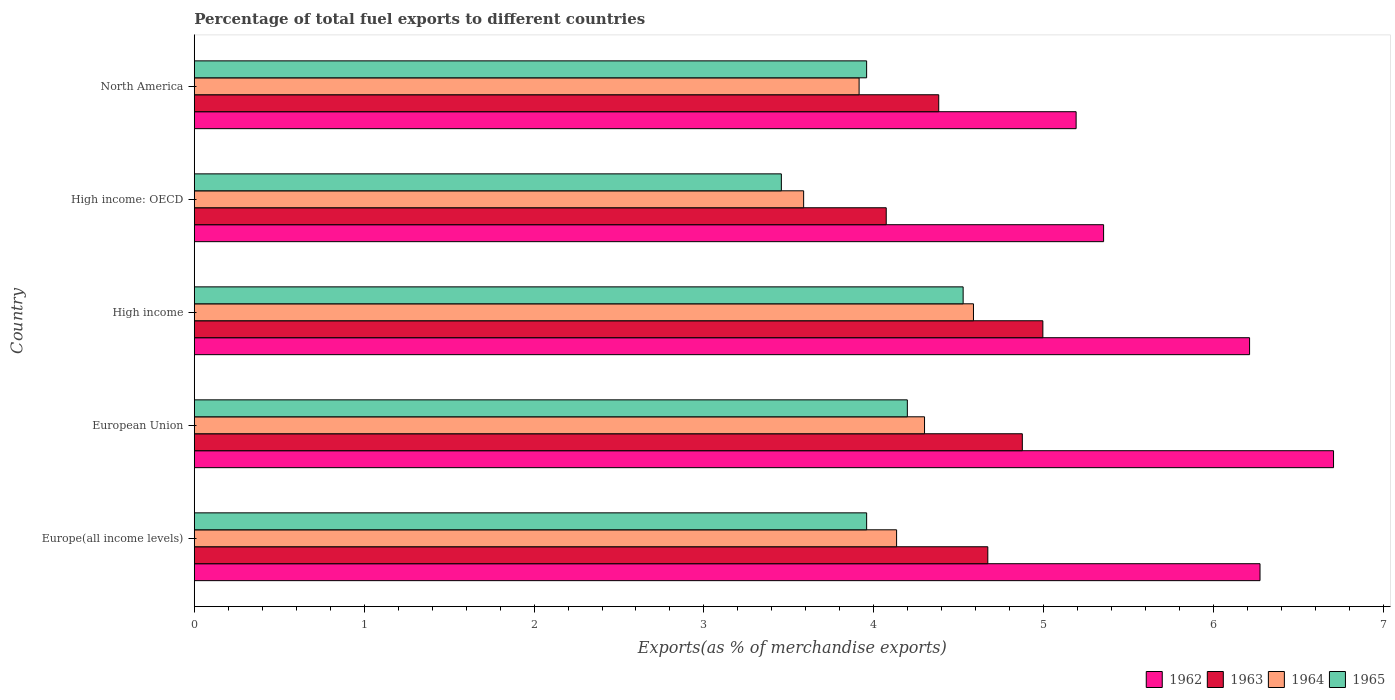How many groups of bars are there?
Make the answer very short. 5. Are the number of bars per tick equal to the number of legend labels?
Make the answer very short. Yes. What is the percentage of exports to different countries in 1963 in High income: OECD?
Give a very brief answer. 4.07. Across all countries, what is the maximum percentage of exports to different countries in 1965?
Provide a short and direct response. 4.53. Across all countries, what is the minimum percentage of exports to different countries in 1964?
Offer a terse response. 3.59. In which country was the percentage of exports to different countries in 1965 maximum?
Make the answer very short. High income. In which country was the percentage of exports to different countries in 1963 minimum?
Your answer should be compact. High income: OECD. What is the total percentage of exports to different countries in 1964 in the graph?
Provide a short and direct response. 20.52. What is the difference between the percentage of exports to different countries in 1962 in Europe(all income levels) and that in High income?
Your answer should be compact. 0.06. What is the difference between the percentage of exports to different countries in 1965 in North America and the percentage of exports to different countries in 1963 in Europe(all income levels)?
Offer a very short reply. -0.71. What is the average percentage of exports to different countries in 1962 per country?
Your response must be concise. 5.95. What is the difference between the percentage of exports to different countries in 1965 and percentage of exports to different countries in 1963 in Europe(all income levels)?
Offer a very short reply. -0.71. In how many countries, is the percentage of exports to different countries in 1964 greater than 5 %?
Provide a succinct answer. 0. What is the ratio of the percentage of exports to different countries in 1964 in European Union to that in High income: OECD?
Keep it short and to the point. 1.2. What is the difference between the highest and the second highest percentage of exports to different countries in 1964?
Offer a very short reply. 0.29. What is the difference between the highest and the lowest percentage of exports to different countries in 1962?
Your answer should be compact. 1.52. Is it the case that in every country, the sum of the percentage of exports to different countries in 1965 and percentage of exports to different countries in 1964 is greater than the sum of percentage of exports to different countries in 1962 and percentage of exports to different countries in 1963?
Give a very brief answer. No. What does the 4th bar from the top in Europe(all income levels) represents?
Keep it short and to the point. 1962. What does the 4th bar from the bottom in European Union represents?
Ensure brevity in your answer.  1965. How many bars are there?
Ensure brevity in your answer.  20. Are all the bars in the graph horizontal?
Your answer should be very brief. Yes. How many countries are there in the graph?
Provide a succinct answer. 5. What is the difference between two consecutive major ticks on the X-axis?
Your answer should be very brief. 1. Does the graph contain any zero values?
Ensure brevity in your answer.  No. Where does the legend appear in the graph?
Give a very brief answer. Bottom right. How many legend labels are there?
Make the answer very short. 4. How are the legend labels stacked?
Make the answer very short. Horizontal. What is the title of the graph?
Offer a very short reply. Percentage of total fuel exports to different countries. What is the label or title of the X-axis?
Provide a succinct answer. Exports(as % of merchandise exports). What is the Exports(as % of merchandise exports) in 1962 in Europe(all income levels)?
Make the answer very short. 6.27. What is the Exports(as % of merchandise exports) of 1963 in Europe(all income levels)?
Provide a succinct answer. 4.67. What is the Exports(as % of merchandise exports) of 1964 in Europe(all income levels)?
Your answer should be very brief. 4.13. What is the Exports(as % of merchandise exports) of 1965 in Europe(all income levels)?
Make the answer very short. 3.96. What is the Exports(as % of merchandise exports) of 1962 in European Union?
Offer a very short reply. 6.71. What is the Exports(as % of merchandise exports) in 1963 in European Union?
Provide a succinct answer. 4.87. What is the Exports(as % of merchandise exports) in 1964 in European Union?
Offer a very short reply. 4.3. What is the Exports(as % of merchandise exports) of 1965 in European Union?
Offer a terse response. 4.2. What is the Exports(as % of merchandise exports) of 1962 in High income?
Make the answer very short. 6.21. What is the Exports(as % of merchandise exports) of 1963 in High income?
Provide a short and direct response. 5. What is the Exports(as % of merchandise exports) of 1964 in High income?
Make the answer very short. 4.59. What is the Exports(as % of merchandise exports) in 1965 in High income?
Your answer should be very brief. 4.53. What is the Exports(as % of merchandise exports) in 1962 in High income: OECD?
Offer a terse response. 5.35. What is the Exports(as % of merchandise exports) in 1963 in High income: OECD?
Keep it short and to the point. 4.07. What is the Exports(as % of merchandise exports) of 1964 in High income: OECD?
Keep it short and to the point. 3.59. What is the Exports(as % of merchandise exports) of 1965 in High income: OECD?
Keep it short and to the point. 3.46. What is the Exports(as % of merchandise exports) of 1962 in North America?
Offer a terse response. 5.19. What is the Exports(as % of merchandise exports) of 1963 in North America?
Make the answer very short. 4.38. What is the Exports(as % of merchandise exports) of 1964 in North America?
Make the answer very short. 3.91. What is the Exports(as % of merchandise exports) in 1965 in North America?
Your response must be concise. 3.96. Across all countries, what is the maximum Exports(as % of merchandise exports) of 1962?
Offer a very short reply. 6.71. Across all countries, what is the maximum Exports(as % of merchandise exports) of 1963?
Provide a short and direct response. 5. Across all countries, what is the maximum Exports(as % of merchandise exports) in 1964?
Your answer should be compact. 4.59. Across all countries, what is the maximum Exports(as % of merchandise exports) in 1965?
Keep it short and to the point. 4.53. Across all countries, what is the minimum Exports(as % of merchandise exports) of 1962?
Offer a very short reply. 5.19. Across all countries, what is the minimum Exports(as % of merchandise exports) of 1963?
Offer a terse response. 4.07. Across all countries, what is the minimum Exports(as % of merchandise exports) in 1964?
Offer a very short reply. 3.59. Across all countries, what is the minimum Exports(as % of merchandise exports) in 1965?
Give a very brief answer. 3.46. What is the total Exports(as % of merchandise exports) in 1962 in the graph?
Your response must be concise. 29.73. What is the total Exports(as % of merchandise exports) of 1963 in the graph?
Your answer should be compact. 23. What is the total Exports(as % of merchandise exports) of 1964 in the graph?
Offer a very short reply. 20.52. What is the total Exports(as % of merchandise exports) of 1965 in the graph?
Ensure brevity in your answer.  20.09. What is the difference between the Exports(as % of merchandise exports) of 1962 in Europe(all income levels) and that in European Union?
Offer a terse response. -0.43. What is the difference between the Exports(as % of merchandise exports) of 1963 in Europe(all income levels) and that in European Union?
Your response must be concise. -0.2. What is the difference between the Exports(as % of merchandise exports) of 1964 in Europe(all income levels) and that in European Union?
Provide a succinct answer. -0.16. What is the difference between the Exports(as % of merchandise exports) of 1965 in Europe(all income levels) and that in European Union?
Keep it short and to the point. -0.24. What is the difference between the Exports(as % of merchandise exports) in 1962 in Europe(all income levels) and that in High income?
Make the answer very short. 0.06. What is the difference between the Exports(as % of merchandise exports) of 1963 in Europe(all income levels) and that in High income?
Your response must be concise. -0.32. What is the difference between the Exports(as % of merchandise exports) in 1964 in Europe(all income levels) and that in High income?
Offer a very short reply. -0.45. What is the difference between the Exports(as % of merchandise exports) of 1965 in Europe(all income levels) and that in High income?
Provide a short and direct response. -0.57. What is the difference between the Exports(as % of merchandise exports) of 1962 in Europe(all income levels) and that in High income: OECD?
Your response must be concise. 0.92. What is the difference between the Exports(as % of merchandise exports) of 1963 in Europe(all income levels) and that in High income: OECD?
Ensure brevity in your answer.  0.6. What is the difference between the Exports(as % of merchandise exports) in 1964 in Europe(all income levels) and that in High income: OECD?
Your response must be concise. 0.55. What is the difference between the Exports(as % of merchandise exports) in 1965 in Europe(all income levels) and that in High income: OECD?
Your answer should be very brief. 0.5. What is the difference between the Exports(as % of merchandise exports) in 1962 in Europe(all income levels) and that in North America?
Your answer should be very brief. 1.08. What is the difference between the Exports(as % of merchandise exports) of 1963 in Europe(all income levels) and that in North America?
Ensure brevity in your answer.  0.29. What is the difference between the Exports(as % of merchandise exports) in 1964 in Europe(all income levels) and that in North America?
Give a very brief answer. 0.22. What is the difference between the Exports(as % of merchandise exports) in 1962 in European Union and that in High income?
Offer a very short reply. 0.49. What is the difference between the Exports(as % of merchandise exports) of 1963 in European Union and that in High income?
Your response must be concise. -0.12. What is the difference between the Exports(as % of merchandise exports) of 1964 in European Union and that in High income?
Ensure brevity in your answer.  -0.29. What is the difference between the Exports(as % of merchandise exports) of 1965 in European Union and that in High income?
Provide a succinct answer. -0.33. What is the difference between the Exports(as % of merchandise exports) of 1962 in European Union and that in High income: OECD?
Make the answer very short. 1.35. What is the difference between the Exports(as % of merchandise exports) of 1963 in European Union and that in High income: OECD?
Provide a short and direct response. 0.8. What is the difference between the Exports(as % of merchandise exports) of 1964 in European Union and that in High income: OECD?
Keep it short and to the point. 0.71. What is the difference between the Exports(as % of merchandise exports) of 1965 in European Union and that in High income: OECD?
Give a very brief answer. 0.74. What is the difference between the Exports(as % of merchandise exports) of 1962 in European Union and that in North America?
Give a very brief answer. 1.52. What is the difference between the Exports(as % of merchandise exports) in 1963 in European Union and that in North America?
Your answer should be compact. 0.49. What is the difference between the Exports(as % of merchandise exports) of 1964 in European Union and that in North America?
Ensure brevity in your answer.  0.39. What is the difference between the Exports(as % of merchandise exports) of 1965 in European Union and that in North America?
Provide a succinct answer. 0.24. What is the difference between the Exports(as % of merchandise exports) of 1962 in High income and that in High income: OECD?
Provide a succinct answer. 0.86. What is the difference between the Exports(as % of merchandise exports) of 1963 in High income and that in High income: OECD?
Give a very brief answer. 0.92. What is the difference between the Exports(as % of merchandise exports) in 1965 in High income and that in High income: OECD?
Offer a very short reply. 1.07. What is the difference between the Exports(as % of merchandise exports) of 1962 in High income and that in North America?
Keep it short and to the point. 1.02. What is the difference between the Exports(as % of merchandise exports) of 1963 in High income and that in North America?
Offer a very short reply. 0.61. What is the difference between the Exports(as % of merchandise exports) of 1964 in High income and that in North America?
Ensure brevity in your answer.  0.67. What is the difference between the Exports(as % of merchandise exports) in 1965 in High income and that in North America?
Give a very brief answer. 0.57. What is the difference between the Exports(as % of merchandise exports) in 1962 in High income: OECD and that in North America?
Offer a very short reply. 0.16. What is the difference between the Exports(as % of merchandise exports) of 1963 in High income: OECD and that in North America?
Offer a terse response. -0.31. What is the difference between the Exports(as % of merchandise exports) of 1964 in High income: OECD and that in North America?
Keep it short and to the point. -0.33. What is the difference between the Exports(as % of merchandise exports) of 1965 in High income: OECD and that in North America?
Offer a very short reply. -0.5. What is the difference between the Exports(as % of merchandise exports) of 1962 in Europe(all income levels) and the Exports(as % of merchandise exports) of 1963 in European Union?
Your response must be concise. 1.4. What is the difference between the Exports(as % of merchandise exports) of 1962 in Europe(all income levels) and the Exports(as % of merchandise exports) of 1964 in European Union?
Provide a short and direct response. 1.97. What is the difference between the Exports(as % of merchandise exports) in 1962 in Europe(all income levels) and the Exports(as % of merchandise exports) in 1965 in European Union?
Provide a succinct answer. 2.08. What is the difference between the Exports(as % of merchandise exports) in 1963 in Europe(all income levels) and the Exports(as % of merchandise exports) in 1964 in European Union?
Offer a terse response. 0.37. What is the difference between the Exports(as % of merchandise exports) in 1963 in Europe(all income levels) and the Exports(as % of merchandise exports) in 1965 in European Union?
Give a very brief answer. 0.47. What is the difference between the Exports(as % of merchandise exports) of 1964 in Europe(all income levels) and the Exports(as % of merchandise exports) of 1965 in European Union?
Offer a terse response. -0.06. What is the difference between the Exports(as % of merchandise exports) of 1962 in Europe(all income levels) and the Exports(as % of merchandise exports) of 1963 in High income?
Ensure brevity in your answer.  1.28. What is the difference between the Exports(as % of merchandise exports) of 1962 in Europe(all income levels) and the Exports(as % of merchandise exports) of 1964 in High income?
Give a very brief answer. 1.69. What is the difference between the Exports(as % of merchandise exports) of 1962 in Europe(all income levels) and the Exports(as % of merchandise exports) of 1965 in High income?
Give a very brief answer. 1.75. What is the difference between the Exports(as % of merchandise exports) of 1963 in Europe(all income levels) and the Exports(as % of merchandise exports) of 1964 in High income?
Provide a succinct answer. 0.08. What is the difference between the Exports(as % of merchandise exports) of 1963 in Europe(all income levels) and the Exports(as % of merchandise exports) of 1965 in High income?
Give a very brief answer. 0.15. What is the difference between the Exports(as % of merchandise exports) of 1964 in Europe(all income levels) and the Exports(as % of merchandise exports) of 1965 in High income?
Your response must be concise. -0.39. What is the difference between the Exports(as % of merchandise exports) of 1962 in Europe(all income levels) and the Exports(as % of merchandise exports) of 1963 in High income: OECD?
Keep it short and to the point. 2.2. What is the difference between the Exports(as % of merchandise exports) of 1962 in Europe(all income levels) and the Exports(as % of merchandise exports) of 1964 in High income: OECD?
Your response must be concise. 2.69. What is the difference between the Exports(as % of merchandise exports) in 1962 in Europe(all income levels) and the Exports(as % of merchandise exports) in 1965 in High income: OECD?
Offer a terse response. 2.82. What is the difference between the Exports(as % of merchandise exports) in 1963 in Europe(all income levels) and the Exports(as % of merchandise exports) in 1964 in High income: OECD?
Your answer should be compact. 1.08. What is the difference between the Exports(as % of merchandise exports) of 1963 in Europe(all income levels) and the Exports(as % of merchandise exports) of 1965 in High income: OECD?
Provide a short and direct response. 1.22. What is the difference between the Exports(as % of merchandise exports) of 1964 in Europe(all income levels) and the Exports(as % of merchandise exports) of 1965 in High income: OECD?
Offer a terse response. 0.68. What is the difference between the Exports(as % of merchandise exports) of 1962 in Europe(all income levels) and the Exports(as % of merchandise exports) of 1963 in North America?
Give a very brief answer. 1.89. What is the difference between the Exports(as % of merchandise exports) in 1962 in Europe(all income levels) and the Exports(as % of merchandise exports) in 1964 in North America?
Ensure brevity in your answer.  2.36. What is the difference between the Exports(as % of merchandise exports) in 1962 in Europe(all income levels) and the Exports(as % of merchandise exports) in 1965 in North America?
Provide a short and direct response. 2.32. What is the difference between the Exports(as % of merchandise exports) in 1963 in Europe(all income levels) and the Exports(as % of merchandise exports) in 1964 in North America?
Give a very brief answer. 0.76. What is the difference between the Exports(as % of merchandise exports) in 1963 in Europe(all income levels) and the Exports(as % of merchandise exports) in 1965 in North America?
Ensure brevity in your answer.  0.71. What is the difference between the Exports(as % of merchandise exports) of 1964 in Europe(all income levels) and the Exports(as % of merchandise exports) of 1965 in North America?
Ensure brevity in your answer.  0.18. What is the difference between the Exports(as % of merchandise exports) of 1962 in European Union and the Exports(as % of merchandise exports) of 1963 in High income?
Make the answer very short. 1.71. What is the difference between the Exports(as % of merchandise exports) in 1962 in European Union and the Exports(as % of merchandise exports) in 1964 in High income?
Your response must be concise. 2.12. What is the difference between the Exports(as % of merchandise exports) of 1962 in European Union and the Exports(as % of merchandise exports) of 1965 in High income?
Offer a terse response. 2.18. What is the difference between the Exports(as % of merchandise exports) of 1963 in European Union and the Exports(as % of merchandise exports) of 1964 in High income?
Provide a short and direct response. 0.29. What is the difference between the Exports(as % of merchandise exports) of 1963 in European Union and the Exports(as % of merchandise exports) of 1965 in High income?
Your response must be concise. 0.35. What is the difference between the Exports(as % of merchandise exports) in 1964 in European Union and the Exports(as % of merchandise exports) in 1965 in High income?
Provide a short and direct response. -0.23. What is the difference between the Exports(as % of merchandise exports) in 1962 in European Union and the Exports(as % of merchandise exports) in 1963 in High income: OECD?
Offer a terse response. 2.63. What is the difference between the Exports(as % of merchandise exports) of 1962 in European Union and the Exports(as % of merchandise exports) of 1964 in High income: OECD?
Ensure brevity in your answer.  3.12. What is the difference between the Exports(as % of merchandise exports) in 1962 in European Union and the Exports(as % of merchandise exports) in 1965 in High income: OECD?
Your answer should be compact. 3.25. What is the difference between the Exports(as % of merchandise exports) of 1963 in European Union and the Exports(as % of merchandise exports) of 1964 in High income: OECD?
Ensure brevity in your answer.  1.29. What is the difference between the Exports(as % of merchandise exports) in 1963 in European Union and the Exports(as % of merchandise exports) in 1965 in High income: OECD?
Give a very brief answer. 1.42. What is the difference between the Exports(as % of merchandise exports) in 1964 in European Union and the Exports(as % of merchandise exports) in 1965 in High income: OECD?
Keep it short and to the point. 0.84. What is the difference between the Exports(as % of merchandise exports) of 1962 in European Union and the Exports(as % of merchandise exports) of 1963 in North America?
Your answer should be compact. 2.32. What is the difference between the Exports(as % of merchandise exports) in 1962 in European Union and the Exports(as % of merchandise exports) in 1964 in North America?
Offer a very short reply. 2.79. What is the difference between the Exports(as % of merchandise exports) in 1962 in European Union and the Exports(as % of merchandise exports) in 1965 in North America?
Provide a succinct answer. 2.75. What is the difference between the Exports(as % of merchandise exports) of 1963 in European Union and the Exports(as % of merchandise exports) of 1964 in North America?
Make the answer very short. 0.96. What is the difference between the Exports(as % of merchandise exports) of 1963 in European Union and the Exports(as % of merchandise exports) of 1965 in North America?
Offer a very short reply. 0.92. What is the difference between the Exports(as % of merchandise exports) in 1964 in European Union and the Exports(as % of merchandise exports) in 1965 in North America?
Give a very brief answer. 0.34. What is the difference between the Exports(as % of merchandise exports) in 1962 in High income and the Exports(as % of merchandise exports) in 1963 in High income: OECD?
Provide a short and direct response. 2.14. What is the difference between the Exports(as % of merchandise exports) of 1962 in High income and the Exports(as % of merchandise exports) of 1964 in High income: OECD?
Your answer should be compact. 2.62. What is the difference between the Exports(as % of merchandise exports) in 1962 in High income and the Exports(as % of merchandise exports) in 1965 in High income: OECD?
Ensure brevity in your answer.  2.76. What is the difference between the Exports(as % of merchandise exports) of 1963 in High income and the Exports(as % of merchandise exports) of 1964 in High income: OECD?
Offer a very short reply. 1.41. What is the difference between the Exports(as % of merchandise exports) of 1963 in High income and the Exports(as % of merchandise exports) of 1965 in High income: OECD?
Keep it short and to the point. 1.54. What is the difference between the Exports(as % of merchandise exports) in 1964 in High income and the Exports(as % of merchandise exports) in 1965 in High income: OECD?
Make the answer very short. 1.13. What is the difference between the Exports(as % of merchandise exports) in 1962 in High income and the Exports(as % of merchandise exports) in 1963 in North America?
Your answer should be very brief. 1.83. What is the difference between the Exports(as % of merchandise exports) of 1962 in High income and the Exports(as % of merchandise exports) of 1964 in North America?
Give a very brief answer. 2.3. What is the difference between the Exports(as % of merchandise exports) in 1962 in High income and the Exports(as % of merchandise exports) in 1965 in North America?
Provide a succinct answer. 2.25. What is the difference between the Exports(as % of merchandise exports) in 1963 in High income and the Exports(as % of merchandise exports) in 1964 in North America?
Ensure brevity in your answer.  1.08. What is the difference between the Exports(as % of merchandise exports) in 1963 in High income and the Exports(as % of merchandise exports) in 1965 in North America?
Keep it short and to the point. 1.04. What is the difference between the Exports(as % of merchandise exports) in 1964 in High income and the Exports(as % of merchandise exports) in 1965 in North America?
Your answer should be very brief. 0.63. What is the difference between the Exports(as % of merchandise exports) of 1962 in High income: OECD and the Exports(as % of merchandise exports) of 1963 in North America?
Your response must be concise. 0.97. What is the difference between the Exports(as % of merchandise exports) in 1962 in High income: OECD and the Exports(as % of merchandise exports) in 1964 in North America?
Provide a short and direct response. 1.44. What is the difference between the Exports(as % of merchandise exports) of 1962 in High income: OECD and the Exports(as % of merchandise exports) of 1965 in North America?
Your response must be concise. 1.39. What is the difference between the Exports(as % of merchandise exports) in 1963 in High income: OECD and the Exports(as % of merchandise exports) in 1964 in North America?
Your response must be concise. 0.16. What is the difference between the Exports(as % of merchandise exports) in 1963 in High income: OECD and the Exports(as % of merchandise exports) in 1965 in North America?
Provide a short and direct response. 0.12. What is the difference between the Exports(as % of merchandise exports) in 1964 in High income: OECD and the Exports(as % of merchandise exports) in 1965 in North America?
Your response must be concise. -0.37. What is the average Exports(as % of merchandise exports) of 1962 per country?
Make the answer very short. 5.95. What is the average Exports(as % of merchandise exports) of 1963 per country?
Offer a very short reply. 4.6. What is the average Exports(as % of merchandise exports) in 1964 per country?
Provide a short and direct response. 4.1. What is the average Exports(as % of merchandise exports) in 1965 per country?
Make the answer very short. 4.02. What is the difference between the Exports(as % of merchandise exports) of 1962 and Exports(as % of merchandise exports) of 1963 in Europe(all income levels)?
Give a very brief answer. 1.6. What is the difference between the Exports(as % of merchandise exports) of 1962 and Exports(as % of merchandise exports) of 1964 in Europe(all income levels)?
Offer a very short reply. 2.14. What is the difference between the Exports(as % of merchandise exports) of 1962 and Exports(as % of merchandise exports) of 1965 in Europe(all income levels)?
Provide a succinct answer. 2.32. What is the difference between the Exports(as % of merchandise exports) of 1963 and Exports(as % of merchandise exports) of 1964 in Europe(all income levels)?
Offer a very short reply. 0.54. What is the difference between the Exports(as % of merchandise exports) in 1963 and Exports(as % of merchandise exports) in 1965 in Europe(all income levels)?
Provide a short and direct response. 0.71. What is the difference between the Exports(as % of merchandise exports) in 1964 and Exports(as % of merchandise exports) in 1965 in Europe(all income levels)?
Keep it short and to the point. 0.18. What is the difference between the Exports(as % of merchandise exports) of 1962 and Exports(as % of merchandise exports) of 1963 in European Union?
Keep it short and to the point. 1.83. What is the difference between the Exports(as % of merchandise exports) of 1962 and Exports(as % of merchandise exports) of 1964 in European Union?
Provide a succinct answer. 2.41. What is the difference between the Exports(as % of merchandise exports) in 1962 and Exports(as % of merchandise exports) in 1965 in European Union?
Your answer should be very brief. 2.51. What is the difference between the Exports(as % of merchandise exports) of 1963 and Exports(as % of merchandise exports) of 1964 in European Union?
Keep it short and to the point. 0.58. What is the difference between the Exports(as % of merchandise exports) in 1963 and Exports(as % of merchandise exports) in 1965 in European Union?
Provide a short and direct response. 0.68. What is the difference between the Exports(as % of merchandise exports) of 1964 and Exports(as % of merchandise exports) of 1965 in European Union?
Offer a very short reply. 0.1. What is the difference between the Exports(as % of merchandise exports) in 1962 and Exports(as % of merchandise exports) in 1963 in High income?
Offer a terse response. 1.22. What is the difference between the Exports(as % of merchandise exports) of 1962 and Exports(as % of merchandise exports) of 1964 in High income?
Provide a succinct answer. 1.63. What is the difference between the Exports(as % of merchandise exports) in 1962 and Exports(as % of merchandise exports) in 1965 in High income?
Offer a very short reply. 1.69. What is the difference between the Exports(as % of merchandise exports) of 1963 and Exports(as % of merchandise exports) of 1964 in High income?
Your response must be concise. 0.41. What is the difference between the Exports(as % of merchandise exports) of 1963 and Exports(as % of merchandise exports) of 1965 in High income?
Provide a short and direct response. 0.47. What is the difference between the Exports(as % of merchandise exports) of 1964 and Exports(as % of merchandise exports) of 1965 in High income?
Provide a succinct answer. 0.06. What is the difference between the Exports(as % of merchandise exports) of 1962 and Exports(as % of merchandise exports) of 1963 in High income: OECD?
Give a very brief answer. 1.28. What is the difference between the Exports(as % of merchandise exports) in 1962 and Exports(as % of merchandise exports) in 1964 in High income: OECD?
Give a very brief answer. 1.77. What is the difference between the Exports(as % of merchandise exports) of 1962 and Exports(as % of merchandise exports) of 1965 in High income: OECD?
Offer a terse response. 1.9. What is the difference between the Exports(as % of merchandise exports) in 1963 and Exports(as % of merchandise exports) in 1964 in High income: OECD?
Your answer should be compact. 0.49. What is the difference between the Exports(as % of merchandise exports) of 1963 and Exports(as % of merchandise exports) of 1965 in High income: OECD?
Give a very brief answer. 0.62. What is the difference between the Exports(as % of merchandise exports) of 1964 and Exports(as % of merchandise exports) of 1965 in High income: OECD?
Keep it short and to the point. 0.13. What is the difference between the Exports(as % of merchandise exports) in 1962 and Exports(as % of merchandise exports) in 1963 in North America?
Provide a succinct answer. 0.81. What is the difference between the Exports(as % of merchandise exports) of 1962 and Exports(as % of merchandise exports) of 1964 in North America?
Make the answer very short. 1.28. What is the difference between the Exports(as % of merchandise exports) of 1962 and Exports(as % of merchandise exports) of 1965 in North America?
Provide a short and direct response. 1.23. What is the difference between the Exports(as % of merchandise exports) of 1963 and Exports(as % of merchandise exports) of 1964 in North America?
Keep it short and to the point. 0.47. What is the difference between the Exports(as % of merchandise exports) of 1963 and Exports(as % of merchandise exports) of 1965 in North America?
Give a very brief answer. 0.42. What is the difference between the Exports(as % of merchandise exports) in 1964 and Exports(as % of merchandise exports) in 1965 in North America?
Your answer should be very brief. -0.04. What is the ratio of the Exports(as % of merchandise exports) of 1962 in Europe(all income levels) to that in European Union?
Offer a terse response. 0.94. What is the ratio of the Exports(as % of merchandise exports) of 1963 in Europe(all income levels) to that in European Union?
Offer a very short reply. 0.96. What is the ratio of the Exports(as % of merchandise exports) of 1964 in Europe(all income levels) to that in European Union?
Ensure brevity in your answer.  0.96. What is the ratio of the Exports(as % of merchandise exports) of 1965 in Europe(all income levels) to that in European Union?
Offer a terse response. 0.94. What is the ratio of the Exports(as % of merchandise exports) of 1962 in Europe(all income levels) to that in High income?
Your answer should be very brief. 1.01. What is the ratio of the Exports(as % of merchandise exports) in 1963 in Europe(all income levels) to that in High income?
Your response must be concise. 0.94. What is the ratio of the Exports(as % of merchandise exports) of 1964 in Europe(all income levels) to that in High income?
Offer a terse response. 0.9. What is the ratio of the Exports(as % of merchandise exports) in 1965 in Europe(all income levels) to that in High income?
Ensure brevity in your answer.  0.87. What is the ratio of the Exports(as % of merchandise exports) of 1962 in Europe(all income levels) to that in High income: OECD?
Your response must be concise. 1.17. What is the ratio of the Exports(as % of merchandise exports) of 1963 in Europe(all income levels) to that in High income: OECD?
Your answer should be compact. 1.15. What is the ratio of the Exports(as % of merchandise exports) of 1964 in Europe(all income levels) to that in High income: OECD?
Ensure brevity in your answer.  1.15. What is the ratio of the Exports(as % of merchandise exports) of 1965 in Europe(all income levels) to that in High income: OECD?
Give a very brief answer. 1.15. What is the ratio of the Exports(as % of merchandise exports) of 1962 in Europe(all income levels) to that in North America?
Make the answer very short. 1.21. What is the ratio of the Exports(as % of merchandise exports) of 1963 in Europe(all income levels) to that in North America?
Offer a terse response. 1.07. What is the ratio of the Exports(as % of merchandise exports) of 1964 in Europe(all income levels) to that in North America?
Provide a succinct answer. 1.06. What is the ratio of the Exports(as % of merchandise exports) of 1965 in Europe(all income levels) to that in North America?
Provide a succinct answer. 1. What is the ratio of the Exports(as % of merchandise exports) of 1962 in European Union to that in High income?
Offer a very short reply. 1.08. What is the ratio of the Exports(as % of merchandise exports) in 1963 in European Union to that in High income?
Your answer should be compact. 0.98. What is the ratio of the Exports(as % of merchandise exports) of 1964 in European Union to that in High income?
Offer a very short reply. 0.94. What is the ratio of the Exports(as % of merchandise exports) in 1965 in European Union to that in High income?
Your answer should be very brief. 0.93. What is the ratio of the Exports(as % of merchandise exports) in 1962 in European Union to that in High income: OECD?
Provide a short and direct response. 1.25. What is the ratio of the Exports(as % of merchandise exports) in 1963 in European Union to that in High income: OECD?
Keep it short and to the point. 1.2. What is the ratio of the Exports(as % of merchandise exports) of 1964 in European Union to that in High income: OECD?
Your answer should be very brief. 1.2. What is the ratio of the Exports(as % of merchandise exports) of 1965 in European Union to that in High income: OECD?
Keep it short and to the point. 1.21. What is the ratio of the Exports(as % of merchandise exports) of 1962 in European Union to that in North America?
Offer a terse response. 1.29. What is the ratio of the Exports(as % of merchandise exports) in 1963 in European Union to that in North America?
Offer a terse response. 1.11. What is the ratio of the Exports(as % of merchandise exports) of 1964 in European Union to that in North America?
Give a very brief answer. 1.1. What is the ratio of the Exports(as % of merchandise exports) of 1965 in European Union to that in North America?
Provide a short and direct response. 1.06. What is the ratio of the Exports(as % of merchandise exports) in 1962 in High income to that in High income: OECD?
Your answer should be very brief. 1.16. What is the ratio of the Exports(as % of merchandise exports) of 1963 in High income to that in High income: OECD?
Ensure brevity in your answer.  1.23. What is the ratio of the Exports(as % of merchandise exports) in 1964 in High income to that in High income: OECD?
Make the answer very short. 1.28. What is the ratio of the Exports(as % of merchandise exports) of 1965 in High income to that in High income: OECD?
Your answer should be compact. 1.31. What is the ratio of the Exports(as % of merchandise exports) of 1962 in High income to that in North America?
Make the answer very short. 1.2. What is the ratio of the Exports(as % of merchandise exports) in 1963 in High income to that in North America?
Ensure brevity in your answer.  1.14. What is the ratio of the Exports(as % of merchandise exports) of 1964 in High income to that in North America?
Make the answer very short. 1.17. What is the ratio of the Exports(as % of merchandise exports) of 1965 in High income to that in North America?
Provide a short and direct response. 1.14. What is the ratio of the Exports(as % of merchandise exports) in 1962 in High income: OECD to that in North America?
Your answer should be very brief. 1.03. What is the ratio of the Exports(as % of merchandise exports) of 1963 in High income: OECD to that in North America?
Give a very brief answer. 0.93. What is the ratio of the Exports(as % of merchandise exports) of 1964 in High income: OECD to that in North America?
Your response must be concise. 0.92. What is the ratio of the Exports(as % of merchandise exports) in 1965 in High income: OECD to that in North America?
Provide a short and direct response. 0.87. What is the difference between the highest and the second highest Exports(as % of merchandise exports) of 1962?
Give a very brief answer. 0.43. What is the difference between the highest and the second highest Exports(as % of merchandise exports) of 1963?
Your response must be concise. 0.12. What is the difference between the highest and the second highest Exports(as % of merchandise exports) in 1964?
Your answer should be very brief. 0.29. What is the difference between the highest and the second highest Exports(as % of merchandise exports) in 1965?
Provide a short and direct response. 0.33. What is the difference between the highest and the lowest Exports(as % of merchandise exports) of 1962?
Keep it short and to the point. 1.52. What is the difference between the highest and the lowest Exports(as % of merchandise exports) in 1963?
Ensure brevity in your answer.  0.92. What is the difference between the highest and the lowest Exports(as % of merchandise exports) of 1965?
Your response must be concise. 1.07. 